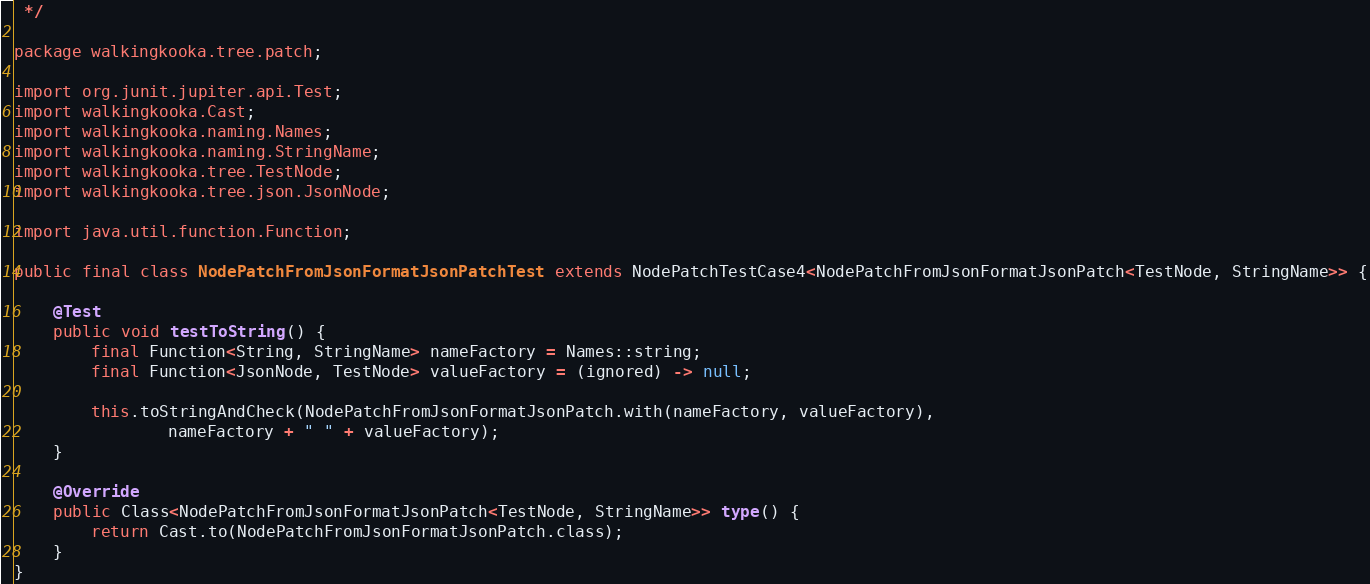<code> <loc_0><loc_0><loc_500><loc_500><_Java_> */

package walkingkooka.tree.patch;

import org.junit.jupiter.api.Test;
import walkingkooka.Cast;
import walkingkooka.naming.Names;
import walkingkooka.naming.StringName;
import walkingkooka.tree.TestNode;
import walkingkooka.tree.json.JsonNode;

import java.util.function.Function;

public final class NodePatchFromJsonFormatJsonPatchTest extends NodePatchTestCase4<NodePatchFromJsonFormatJsonPatch<TestNode, StringName>> {

    @Test
    public void testToString() {
        final Function<String, StringName> nameFactory = Names::string;
        final Function<JsonNode, TestNode> valueFactory = (ignored) -> null;

        this.toStringAndCheck(NodePatchFromJsonFormatJsonPatch.with(nameFactory, valueFactory),
                nameFactory + " " + valueFactory);
    }

    @Override
    public Class<NodePatchFromJsonFormatJsonPatch<TestNode, StringName>> type() {
        return Cast.to(NodePatchFromJsonFormatJsonPatch.class);
    }
}
</code> 